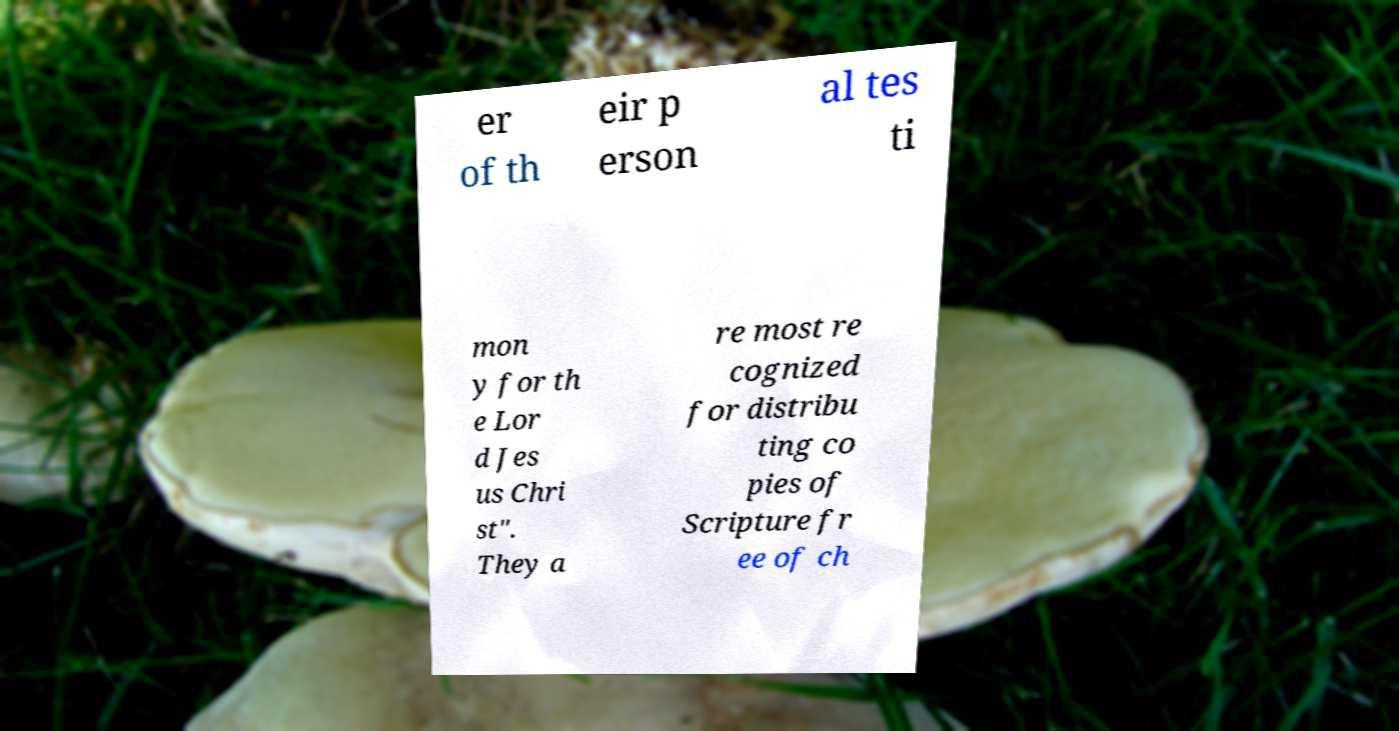Can you read and provide the text displayed in the image?This photo seems to have some interesting text. Can you extract and type it out for me? er of th eir p erson al tes ti mon y for th e Lor d Jes us Chri st". They a re most re cognized for distribu ting co pies of Scripture fr ee of ch 